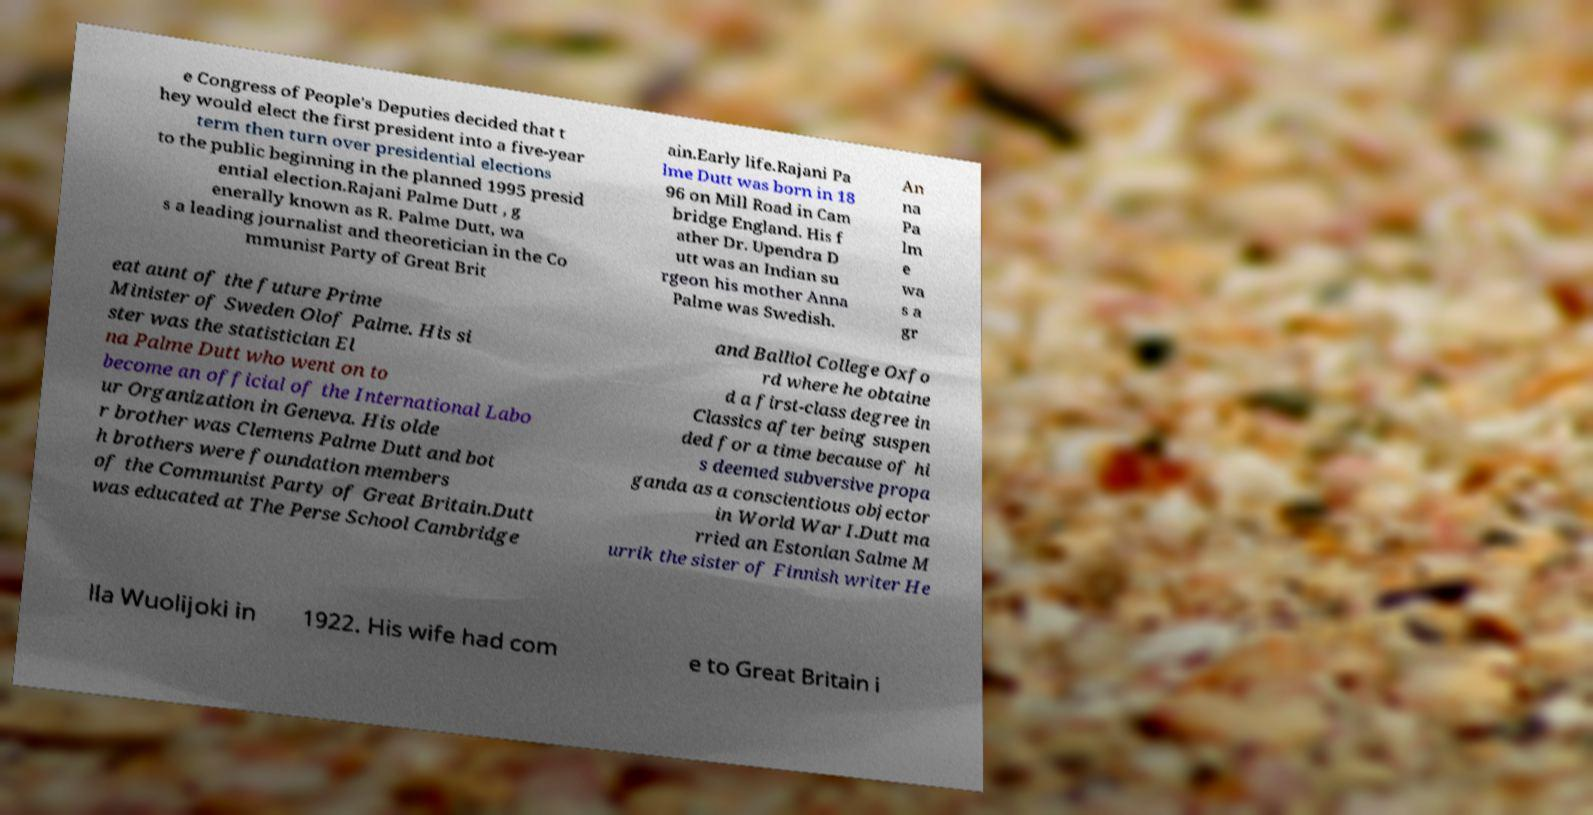Can you read and provide the text displayed in the image?This photo seems to have some interesting text. Can you extract and type it out for me? e Congress of People's Deputies decided that t hey would elect the first president into a five-year term then turn over presidential elections to the public beginning in the planned 1995 presid ential election.Rajani Palme Dutt , g enerally known as R. Palme Dutt, wa s a leading journalist and theoretician in the Co mmunist Party of Great Brit ain.Early life.Rajani Pa lme Dutt was born in 18 96 on Mill Road in Cam bridge England. His f ather Dr. Upendra D utt was an Indian su rgeon his mother Anna Palme was Swedish. An na Pa lm e wa s a gr eat aunt of the future Prime Minister of Sweden Olof Palme. His si ster was the statistician El na Palme Dutt who went on to become an official of the International Labo ur Organization in Geneva. His olde r brother was Clemens Palme Dutt and bot h brothers were foundation members of the Communist Party of Great Britain.Dutt was educated at The Perse School Cambridge and Balliol College Oxfo rd where he obtaine d a first-class degree in Classics after being suspen ded for a time because of hi s deemed subversive propa ganda as a conscientious objector in World War I.Dutt ma rried an Estonian Salme M urrik the sister of Finnish writer He lla Wuolijoki in 1922. His wife had com e to Great Britain i 